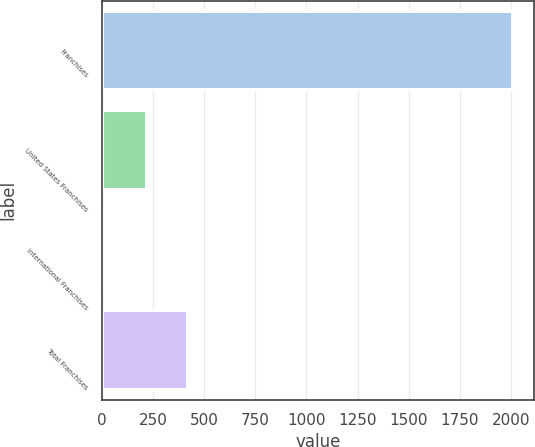<chart> <loc_0><loc_0><loc_500><loc_500><bar_chart><fcel>Franchises<fcel>United States Franchises<fcel>International Franchises<fcel>Total Franchises<nl><fcel>2012<fcel>221<fcel>22<fcel>420<nl></chart> 